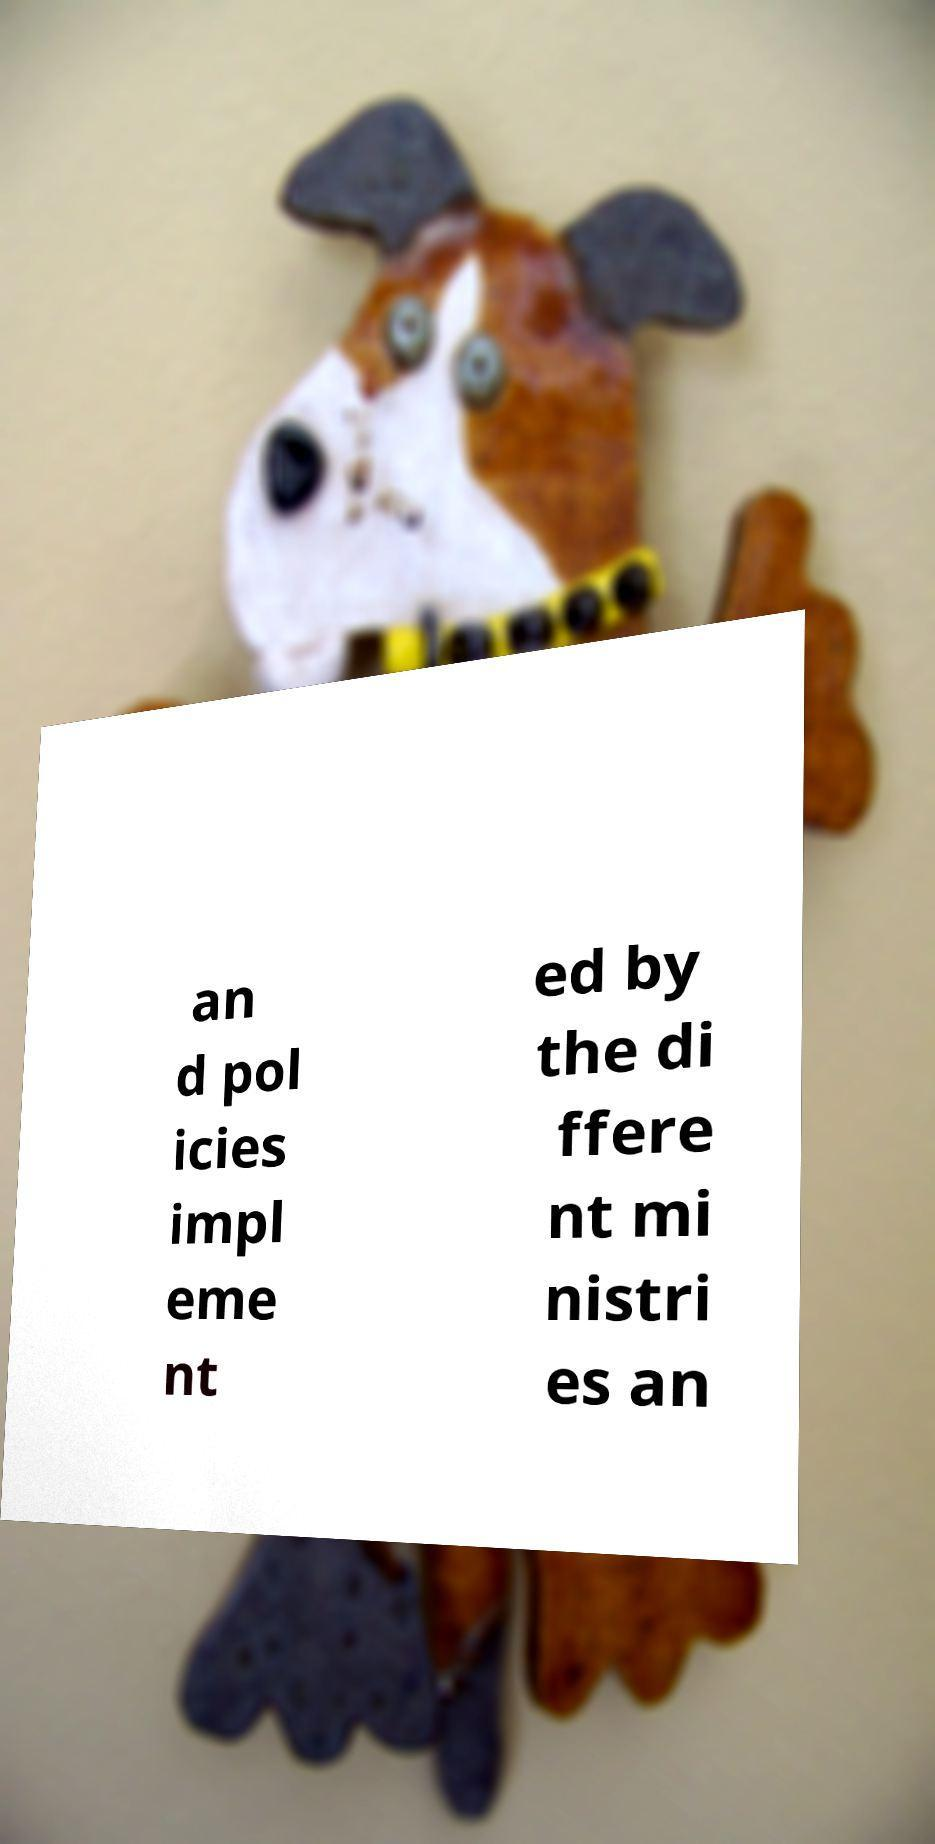Please identify and transcribe the text found in this image. an d pol icies impl eme nt ed by the di ffere nt mi nistri es an 